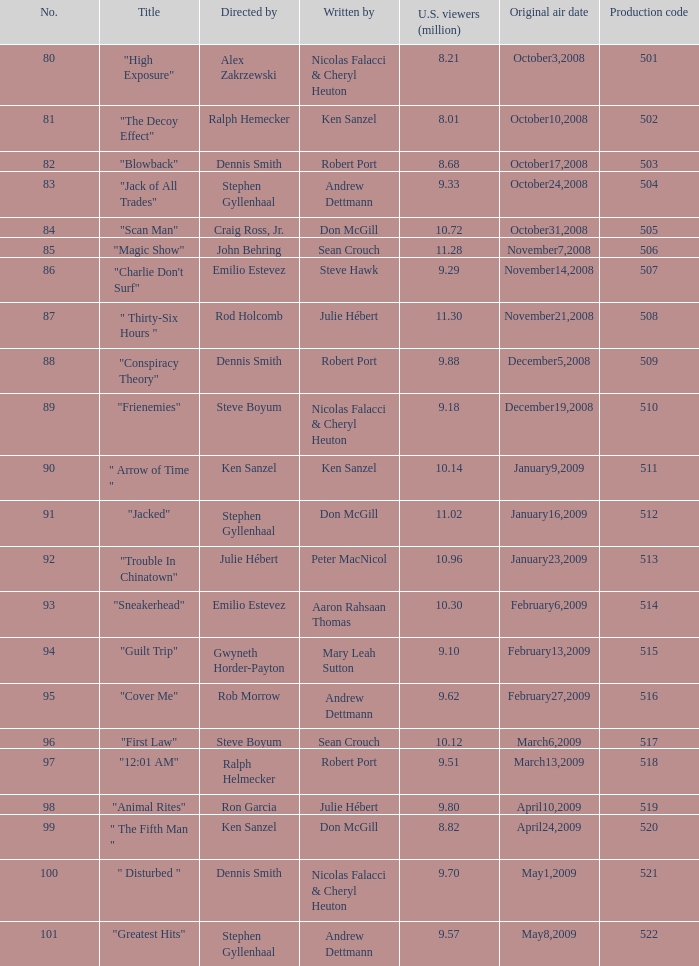Who wrote the episode with the production code 519? Julie Hébert. 